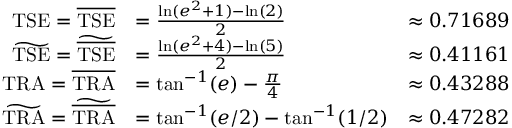<formula> <loc_0><loc_0><loc_500><loc_500>\begin{array} { r l r } { T S E = \overline { T S E } } & { = \frac { \ln ( e ^ { 2 } + 1 ) - \ln ( 2 ) } { 2 } } & { \approx 0 . 7 1 6 8 9 } \\ { \widetilde { T S E } = \widetilde { \overline { T S E } } } & { = \frac { \ln ( e ^ { 2 } + 4 ) - \ln ( 5 ) } { 2 } } & { \approx 0 . 4 1 1 6 1 } \\ { T R A = \overline { T R A } } & { = \tan ^ { - 1 } ( e ) - \frac { \pi } { 4 } } & { \approx 0 . 4 3 2 8 8 } \\ { \widetilde { T R A } = \widetilde { \overline { T R A } } } & { = \tan ^ { - 1 } ( e / 2 ) - \tan ^ { - 1 } ( 1 / 2 ) } & { \approx 0 . 4 7 2 8 2 } \end{array}</formula> 